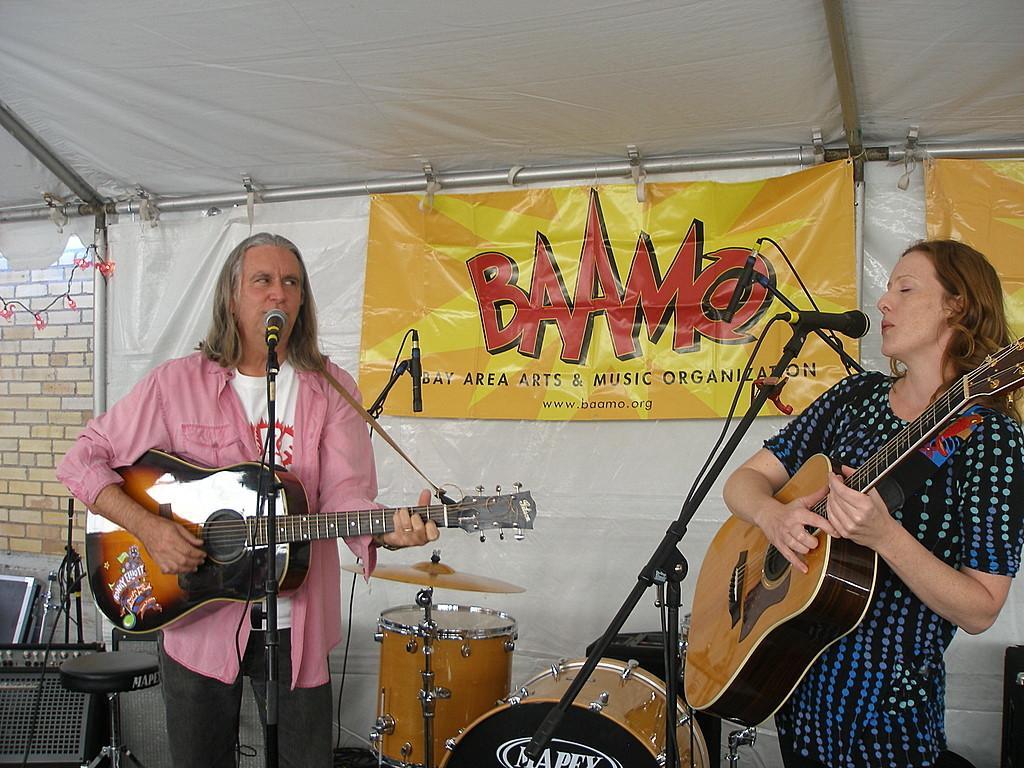Can you describe this image briefly? As we can see in the image there is a brick wall, banner, two people singing and holding guitar in their hands and in the middle there are musical drums. 